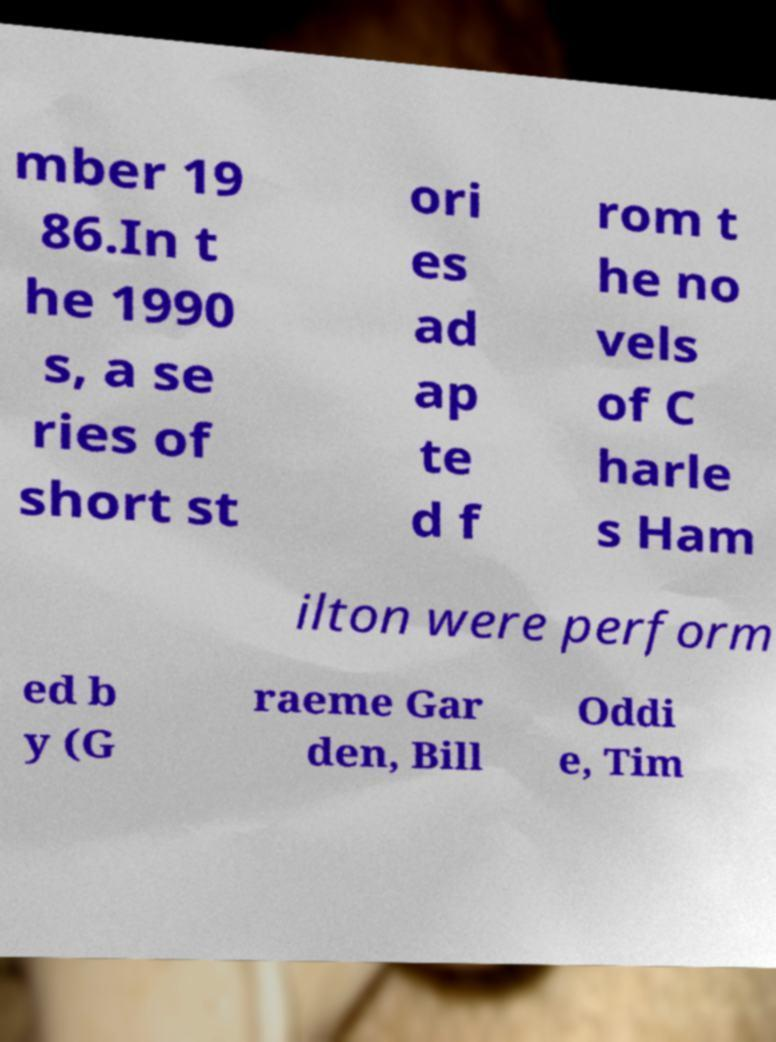Can you accurately transcribe the text from the provided image for me? mber 19 86.In t he 1990 s, a se ries of short st ori es ad ap te d f rom t he no vels of C harle s Ham ilton were perform ed b y (G raeme Gar den, Bill Oddi e, Tim 